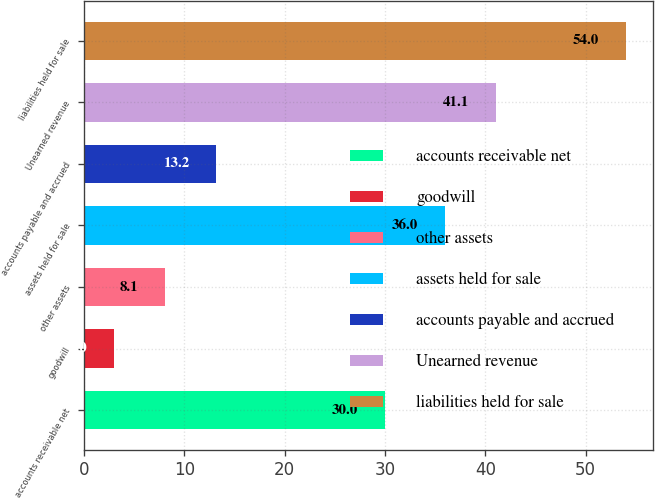Convert chart. <chart><loc_0><loc_0><loc_500><loc_500><bar_chart><fcel>accounts receivable net<fcel>goodwill<fcel>other assets<fcel>assets held for sale<fcel>accounts payable and accrued<fcel>Unearned revenue<fcel>liabilities held for sale<nl><fcel>30<fcel>3<fcel>8.1<fcel>36<fcel>13.2<fcel>41.1<fcel>54<nl></chart> 